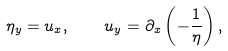Convert formula to latex. <formula><loc_0><loc_0><loc_500><loc_500>\eta _ { y } = u _ { x } , \quad u _ { y } = \partial _ { x } \left ( - \frac { 1 } { \eta } \right ) ,</formula> 